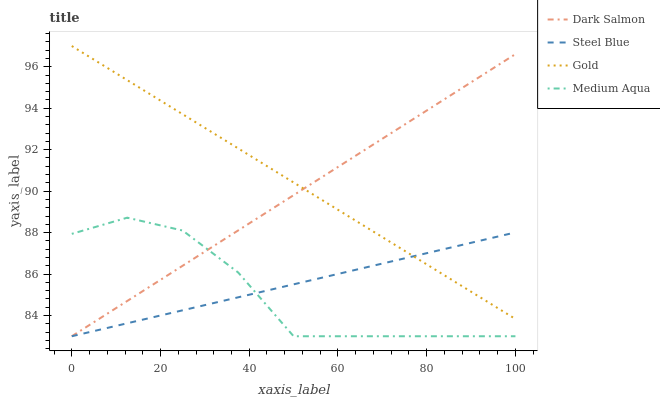Does Medium Aqua have the minimum area under the curve?
Answer yes or no. Yes. Does Gold have the maximum area under the curve?
Answer yes or no. Yes. Does Dark Salmon have the minimum area under the curve?
Answer yes or no. No. Does Dark Salmon have the maximum area under the curve?
Answer yes or no. No. Is Dark Salmon the smoothest?
Answer yes or no. Yes. Is Medium Aqua the roughest?
Answer yes or no. Yes. Is Gold the smoothest?
Answer yes or no. No. Is Gold the roughest?
Answer yes or no. No. Does Medium Aqua have the lowest value?
Answer yes or no. Yes. Does Gold have the lowest value?
Answer yes or no. No. Does Gold have the highest value?
Answer yes or no. Yes. Does Dark Salmon have the highest value?
Answer yes or no. No. Is Medium Aqua less than Gold?
Answer yes or no. Yes. Is Gold greater than Medium Aqua?
Answer yes or no. Yes. Does Gold intersect Dark Salmon?
Answer yes or no. Yes. Is Gold less than Dark Salmon?
Answer yes or no. No. Is Gold greater than Dark Salmon?
Answer yes or no. No. Does Medium Aqua intersect Gold?
Answer yes or no. No. 